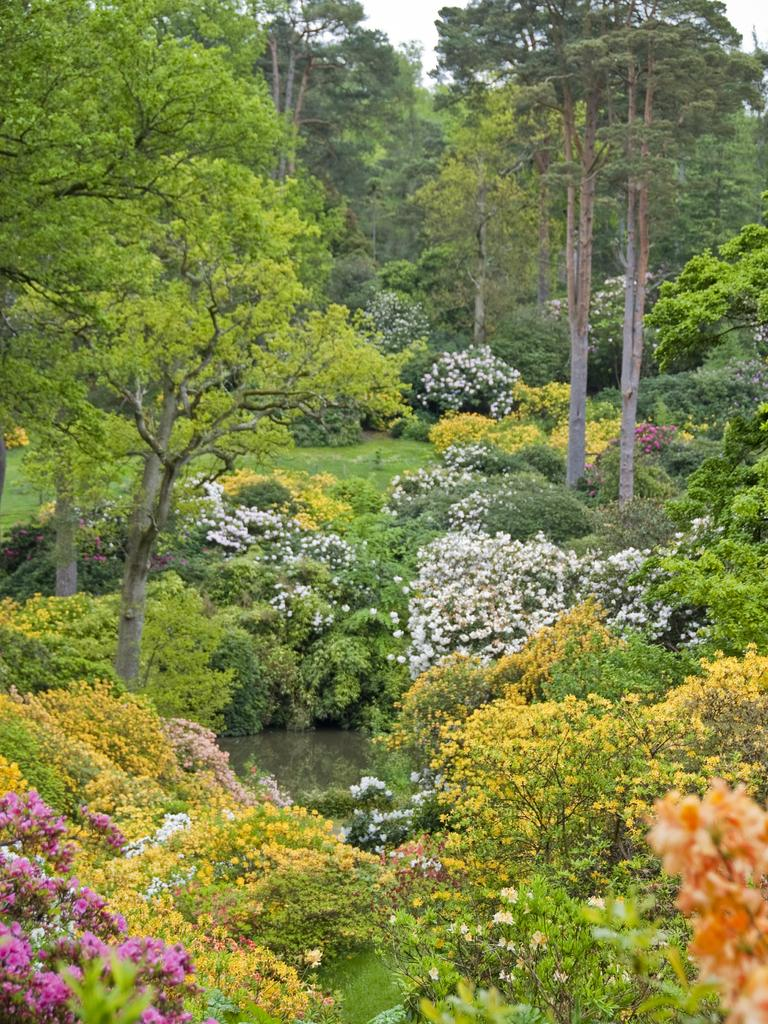What type of vegetation can be seen in the image? There are plants and trees in the image. What can be seen between the plants? There is water visible between the plants. What is visible in the background of the image? The sky is visible in the background of the image. What type of honey can be seen dripping from the trees in the image? There is no honey present in the image; it features plants, trees, water, and the sky. What color is the straw used to stir the plants in the image? There is no straw present in the image, as it focuses on plants, trees, water, and the sky. 